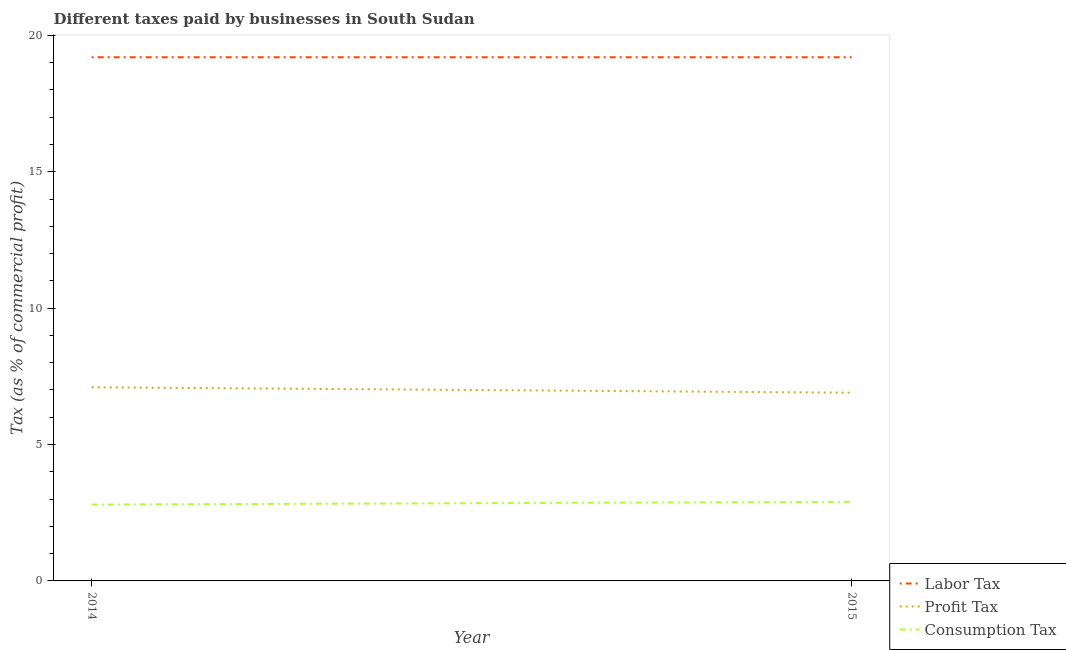Does the line corresponding to percentage of profit tax intersect with the line corresponding to percentage of labor tax?
Make the answer very short. No. What is the percentage of profit tax in 2015?
Keep it short and to the point. 6.9. Across all years, what is the maximum percentage of profit tax?
Keep it short and to the point. 7.1. In which year was the percentage of consumption tax maximum?
Provide a short and direct response. 2015. In which year was the percentage of profit tax minimum?
Offer a very short reply. 2015. What is the difference between the percentage of consumption tax in 2014 and that in 2015?
Your response must be concise. -0.1. What is the difference between the percentage of consumption tax in 2015 and the percentage of profit tax in 2014?
Give a very brief answer. -4.2. In the year 2014, what is the difference between the percentage of consumption tax and percentage of labor tax?
Provide a succinct answer. -16.4. What is the ratio of the percentage of consumption tax in 2014 to that in 2015?
Keep it short and to the point. 0.97. Is the percentage of consumption tax in 2014 less than that in 2015?
Your answer should be very brief. Yes. Does the percentage of profit tax monotonically increase over the years?
Make the answer very short. No. Is the percentage of labor tax strictly greater than the percentage of profit tax over the years?
Give a very brief answer. Yes. Is the percentage of profit tax strictly less than the percentage of labor tax over the years?
Offer a very short reply. Yes. Are the values on the major ticks of Y-axis written in scientific E-notation?
Your answer should be very brief. No. Does the graph contain any zero values?
Provide a succinct answer. No. How many legend labels are there?
Offer a terse response. 3. What is the title of the graph?
Your answer should be very brief. Different taxes paid by businesses in South Sudan. Does "Financial account" appear as one of the legend labels in the graph?
Your answer should be very brief. No. What is the label or title of the Y-axis?
Offer a very short reply. Tax (as % of commercial profit). What is the Tax (as % of commercial profit) in Consumption Tax in 2014?
Keep it short and to the point. 2.8. What is the Tax (as % of commercial profit) of Consumption Tax in 2015?
Make the answer very short. 2.9. Across all years, what is the maximum Tax (as % of commercial profit) of Consumption Tax?
Give a very brief answer. 2.9. Across all years, what is the minimum Tax (as % of commercial profit) of Labor Tax?
Ensure brevity in your answer.  19.2. What is the total Tax (as % of commercial profit) in Labor Tax in the graph?
Provide a succinct answer. 38.4. What is the total Tax (as % of commercial profit) in Profit Tax in the graph?
Your answer should be compact. 14. What is the total Tax (as % of commercial profit) in Consumption Tax in the graph?
Offer a terse response. 5.7. What is the difference between the Tax (as % of commercial profit) in Consumption Tax in 2014 and that in 2015?
Offer a very short reply. -0.1. What is the difference between the Tax (as % of commercial profit) in Labor Tax in 2014 and the Tax (as % of commercial profit) in Profit Tax in 2015?
Ensure brevity in your answer.  12.3. What is the difference between the Tax (as % of commercial profit) in Profit Tax in 2014 and the Tax (as % of commercial profit) in Consumption Tax in 2015?
Your answer should be compact. 4.2. What is the average Tax (as % of commercial profit) in Labor Tax per year?
Your response must be concise. 19.2. What is the average Tax (as % of commercial profit) in Profit Tax per year?
Offer a terse response. 7. What is the average Tax (as % of commercial profit) in Consumption Tax per year?
Keep it short and to the point. 2.85. In the year 2014, what is the difference between the Tax (as % of commercial profit) in Labor Tax and Tax (as % of commercial profit) in Consumption Tax?
Your response must be concise. 16.4. In the year 2014, what is the difference between the Tax (as % of commercial profit) in Profit Tax and Tax (as % of commercial profit) in Consumption Tax?
Ensure brevity in your answer.  4.3. In the year 2015, what is the difference between the Tax (as % of commercial profit) in Labor Tax and Tax (as % of commercial profit) in Consumption Tax?
Your answer should be very brief. 16.3. What is the ratio of the Tax (as % of commercial profit) in Consumption Tax in 2014 to that in 2015?
Offer a very short reply. 0.97. What is the difference between the highest and the second highest Tax (as % of commercial profit) in Labor Tax?
Ensure brevity in your answer.  0. What is the difference between the highest and the second highest Tax (as % of commercial profit) in Consumption Tax?
Give a very brief answer. 0.1. What is the difference between the highest and the lowest Tax (as % of commercial profit) in Profit Tax?
Your response must be concise. 0.2. What is the difference between the highest and the lowest Tax (as % of commercial profit) of Consumption Tax?
Offer a very short reply. 0.1. 